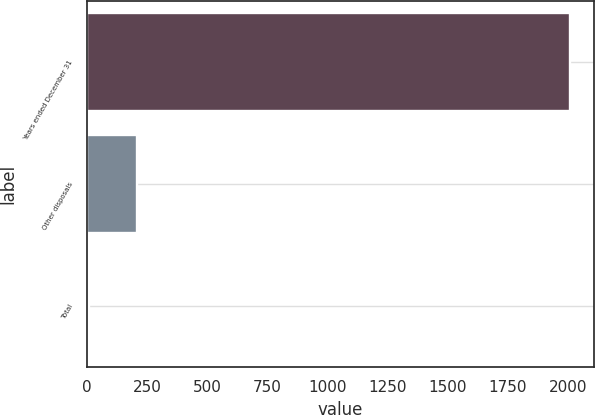Convert chart. <chart><loc_0><loc_0><loc_500><loc_500><bar_chart><fcel>Years ended December 31<fcel>Other disposals<fcel>Total<nl><fcel>2008<fcel>208<fcel>8<nl></chart> 